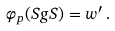<formula> <loc_0><loc_0><loc_500><loc_500>\varphi _ { p } ( S g S ) = w ^ { \prime } \, .</formula> 